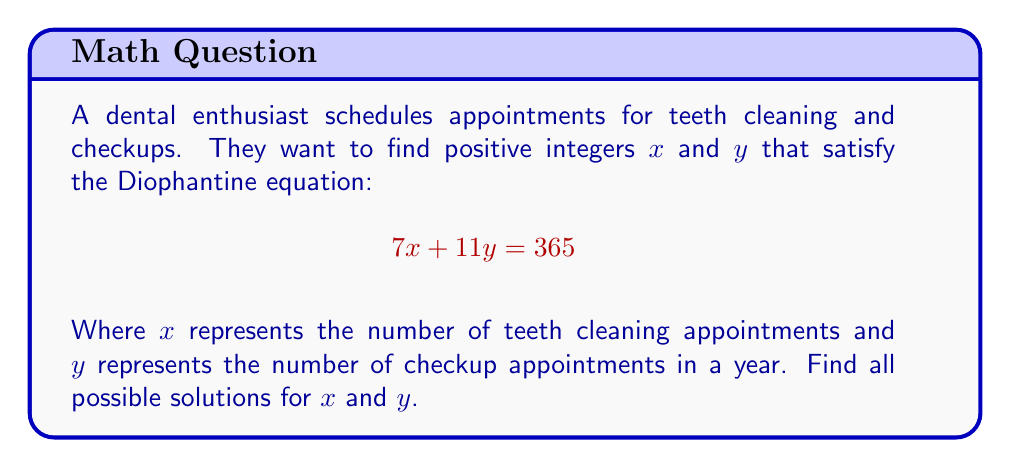Could you help me with this problem? Let's solve this Diophantine equation step by step:

1) First, we need to find a particular solution. We can use the Euclidean algorithm:

   $365 = 7 \cdot 52 + 1$
   $7 = 7 \cdot 1 + 0$

   Working backwards:
   $1 = 365 - 7 \cdot 52$
   $1 = 365 - 7 \cdot 52 = 365 + 7(-52)$

2) Multiply both sides by 11:
   $11 = 11 \cdot 365 + 7(-572)$

3) Now we have a particular solution: $x_0 = -572, y_0 = 365$

4) The general solution is given by:
   $x = x_0 + 11t = -572 + 11t$
   $y = y_0 - 7t = 365 - 7t$
   where $t$ is an integer.

5) Since we need positive integers, we solve:
   $-572 + 11t > 0$ and $365 - 7t > 0$

6) From the first inequality:
   $11t > 572$
   $t > 52$

7) From the second inequality:
   $-7t > -365$
   $t < 52.14$

8) Combining these, we get:
   $52 < t < 52.14$

9) The only integer value of $t$ that satisfies this is 52.

10) Substituting $t = 52$ into our general solution:
    $x = -572 + 11(52) = -572 + 572 = 0$
    $y = 365 - 7(52) = 365 - 364 = 1$

11) However, $x = 0$ doesn't satisfy our requirement for positive integers.

12) The next possible value is $t = 53$, which gives:
    $x = -572 + 11(53) = 11$
    $y = 365 - 7(53) = 365 - 371 = -6$

13) The next value that gives positive integers for both $x$ and $y$ is $t = 54$:
    $x = -572 + 11(54) = 22$
    $y = 365 - 7(54) = 365 - 378 = -13$

Therefore, there are no positive integer solutions for $x$ and $y$.
Answer: No positive integer solutions exist. 